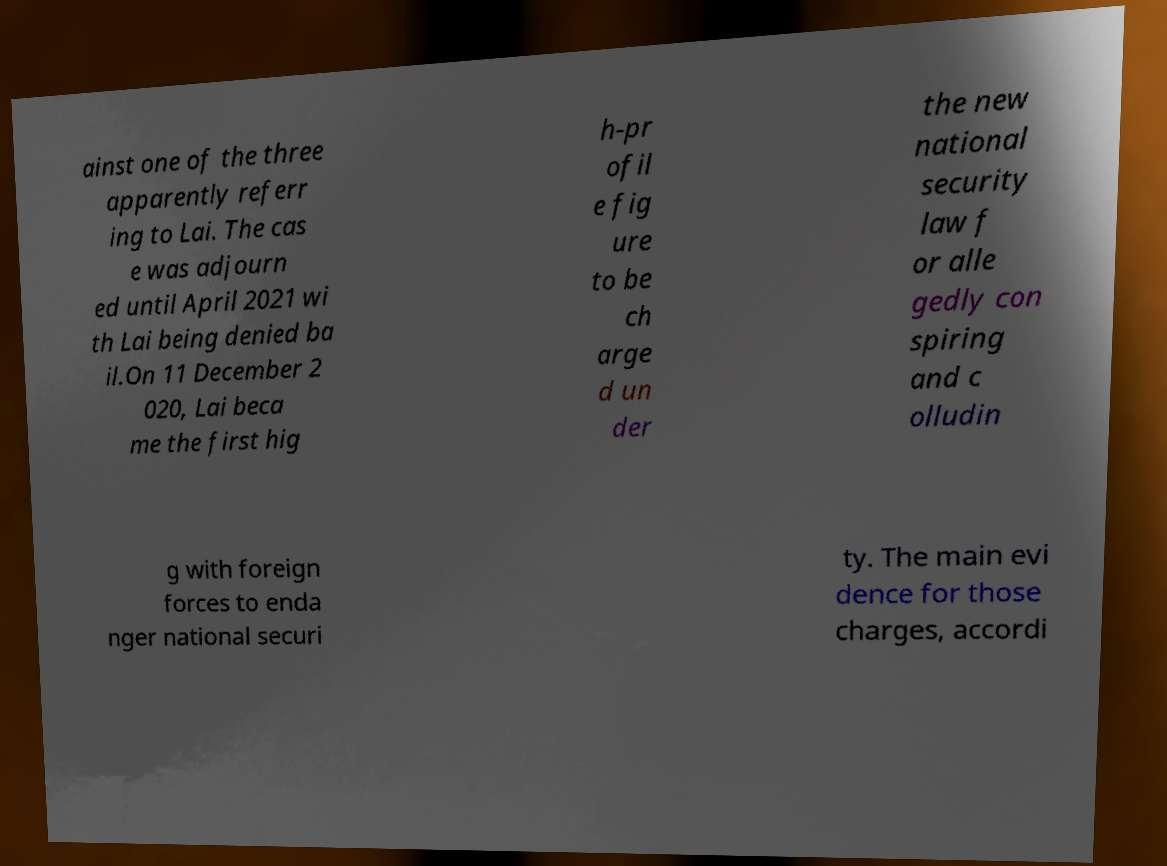I need the written content from this picture converted into text. Can you do that? ainst one of the three apparently referr ing to Lai. The cas e was adjourn ed until April 2021 wi th Lai being denied ba il.On 11 December 2 020, Lai beca me the first hig h-pr ofil e fig ure to be ch arge d un der the new national security law f or alle gedly con spiring and c olludin g with foreign forces to enda nger national securi ty. The main evi dence for those charges, accordi 